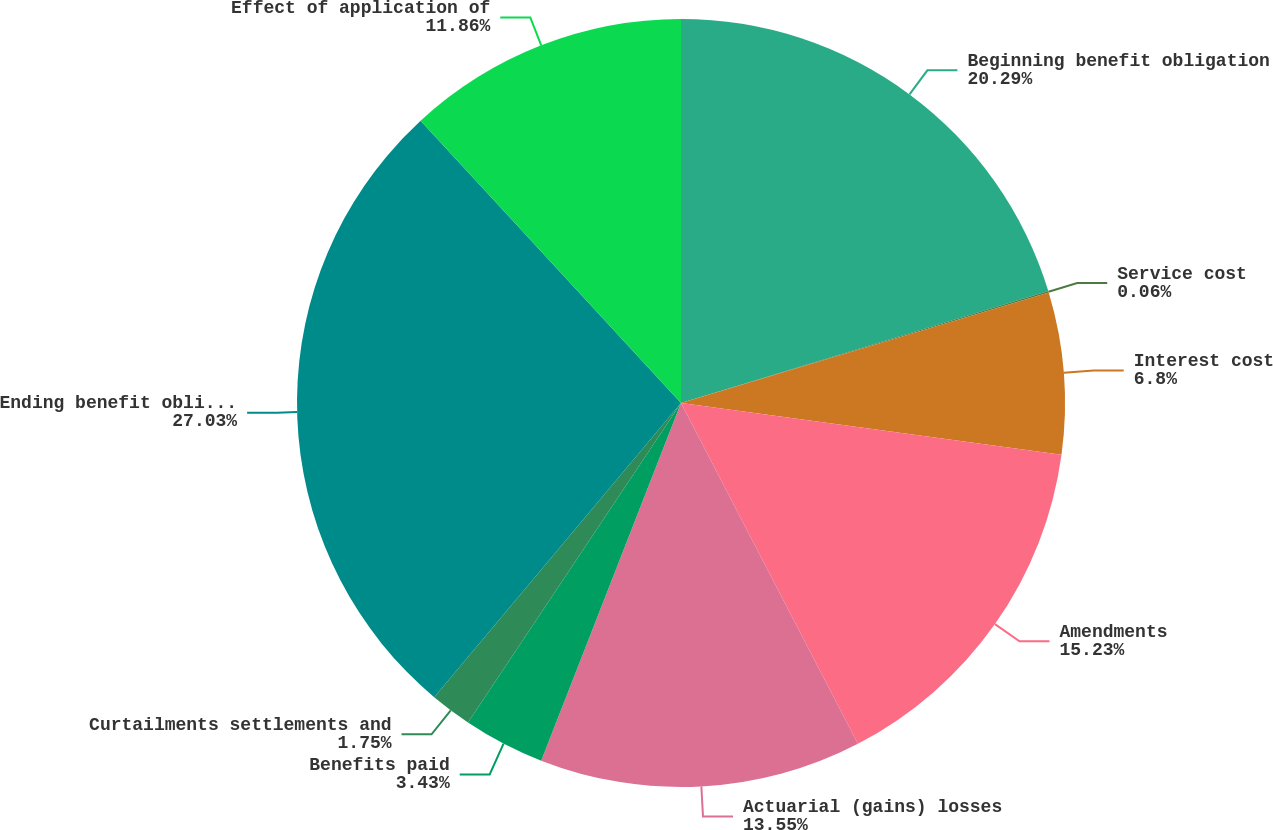Convert chart to OTSL. <chart><loc_0><loc_0><loc_500><loc_500><pie_chart><fcel>Beginning benefit obligation<fcel>Service cost<fcel>Interest cost<fcel>Amendments<fcel>Actuarial (gains) losses<fcel>Benefits paid<fcel>Curtailments settlements and<fcel>Ending benefit obligation<fcel>Effect of application of<nl><fcel>20.29%<fcel>0.06%<fcel>6.8%<fcel>15.23%<fcel>13.55%<fcel>3.43%<fcel>1.75%<fcel>27.03%<fcel>11.86%<nl></chart> 